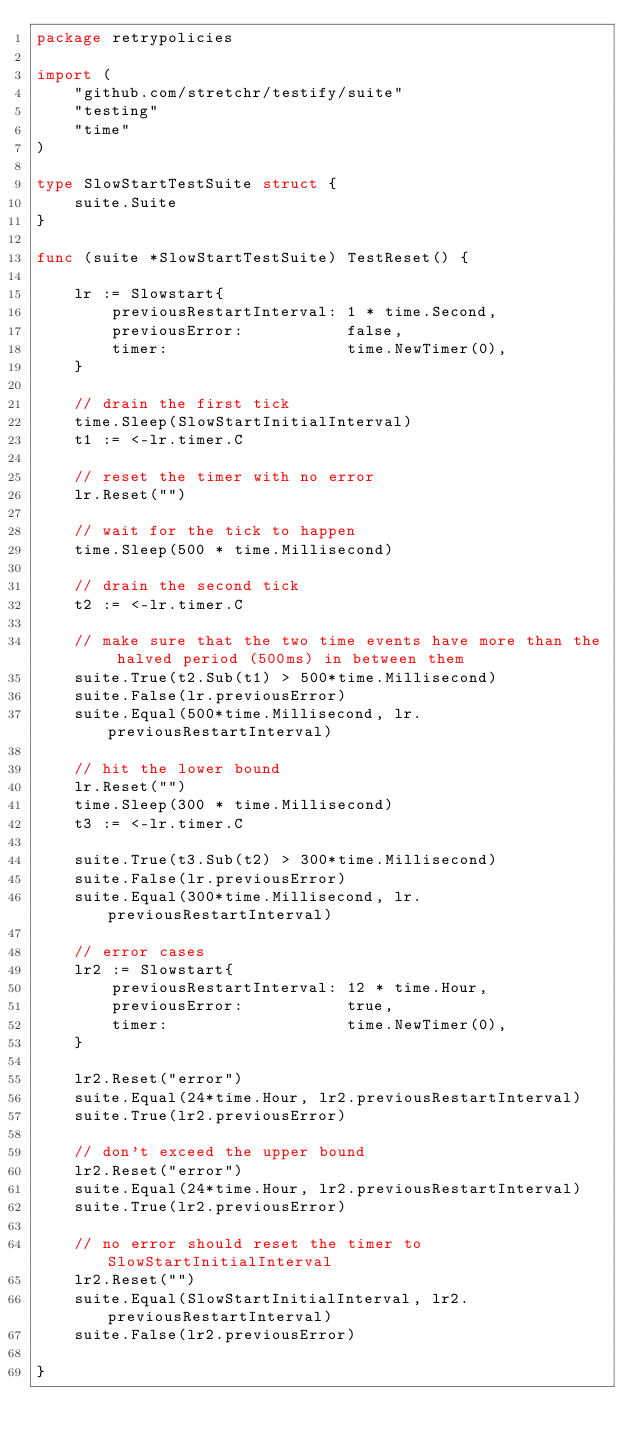Convert code to text. <code><loc_0><loc_0><loc_500><loc_500><_Go_>package retrypolicies

import (
	"github.com/stretchr/testify/suite"
	"testing"
	"time"
)

type SlowStartTestSuite struct {
	suite.Suite
}

func (suite *SlowStartTestSuite) TestReset() {

	lr := Slowstart{
		previousRestartInterval: 1 * time.Second,
		previousError:           false,
		timer:                   time.NewTimer(0),
	}

	// drain the first tick
	time.Sleep(SlowStartInitialInterval)
	t1 := <-lr.timer.C

	// reset the timer with no error
	lr.Reset("")

	// wait for the tick to happen
	time.Sleep(500 * time.Millisecond)

	// drain the second tick
	t2 := <-lr.timer.C

	// make sure that the two time events have more than the halved period (500ms) in between them
	suite.True(t2.Sub(t1) > 500*time.Millisecond)
	suite.False(lr.previousError)
	suite.Equal(500*time.Millisecond, lr.previousRestartInterval)

	// hit the lower bound
	lr.Reset("")
	time.Sleep(300 * time.Millisecond)
	t3 := <-lr.timer.C

	suite.True(t3.Sub(t2) > 300*time.Millisecond)
	suite.False(lr.previousError)
	suite.Equal(300*time.Millisecond, lr.previousRestartInterval)

	// error cases
	lr2 := Slowstart{
		previousRestartInterval: 12 * time.Hour,
		previousError:           true,
		timer:                   time.NewTimer(0),
	}

	lr2.Reset("error")
	suite.Equal(24*time.Hour, lr2.previousRestartInterval)
	suite.True(lr2.previousError)

	// don't exceed the upper bound
	lr2.Reset("error")
	suite.Equal(24*time.Hour, lr2.previousRestartInterval)
	suite.True(lr2.previousError)

	// no error should reset the timer to SlowStartInitialInterval
	lr2.Reset("")
	suite.Equal(SlowStartInitialInterval, lr2.previousRestartInterval)
	suite.False(lr2.previousError)

}
</code> 